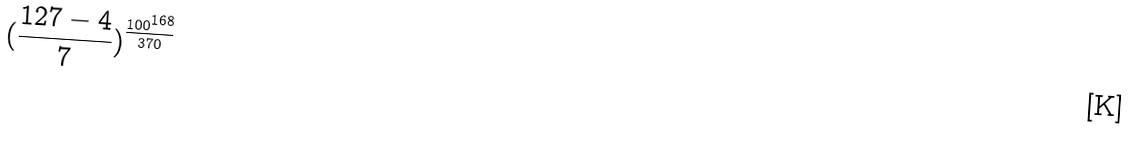Convert formula to latex. <formula><loc_0><loc_0><loc_500><loc_500>( \frac { 1 2 7 - 4 } { 7 } ) ^ { \frac { 1 0 0 ^ { 1 6 8 } } { 3 7 0 } }</formula> 